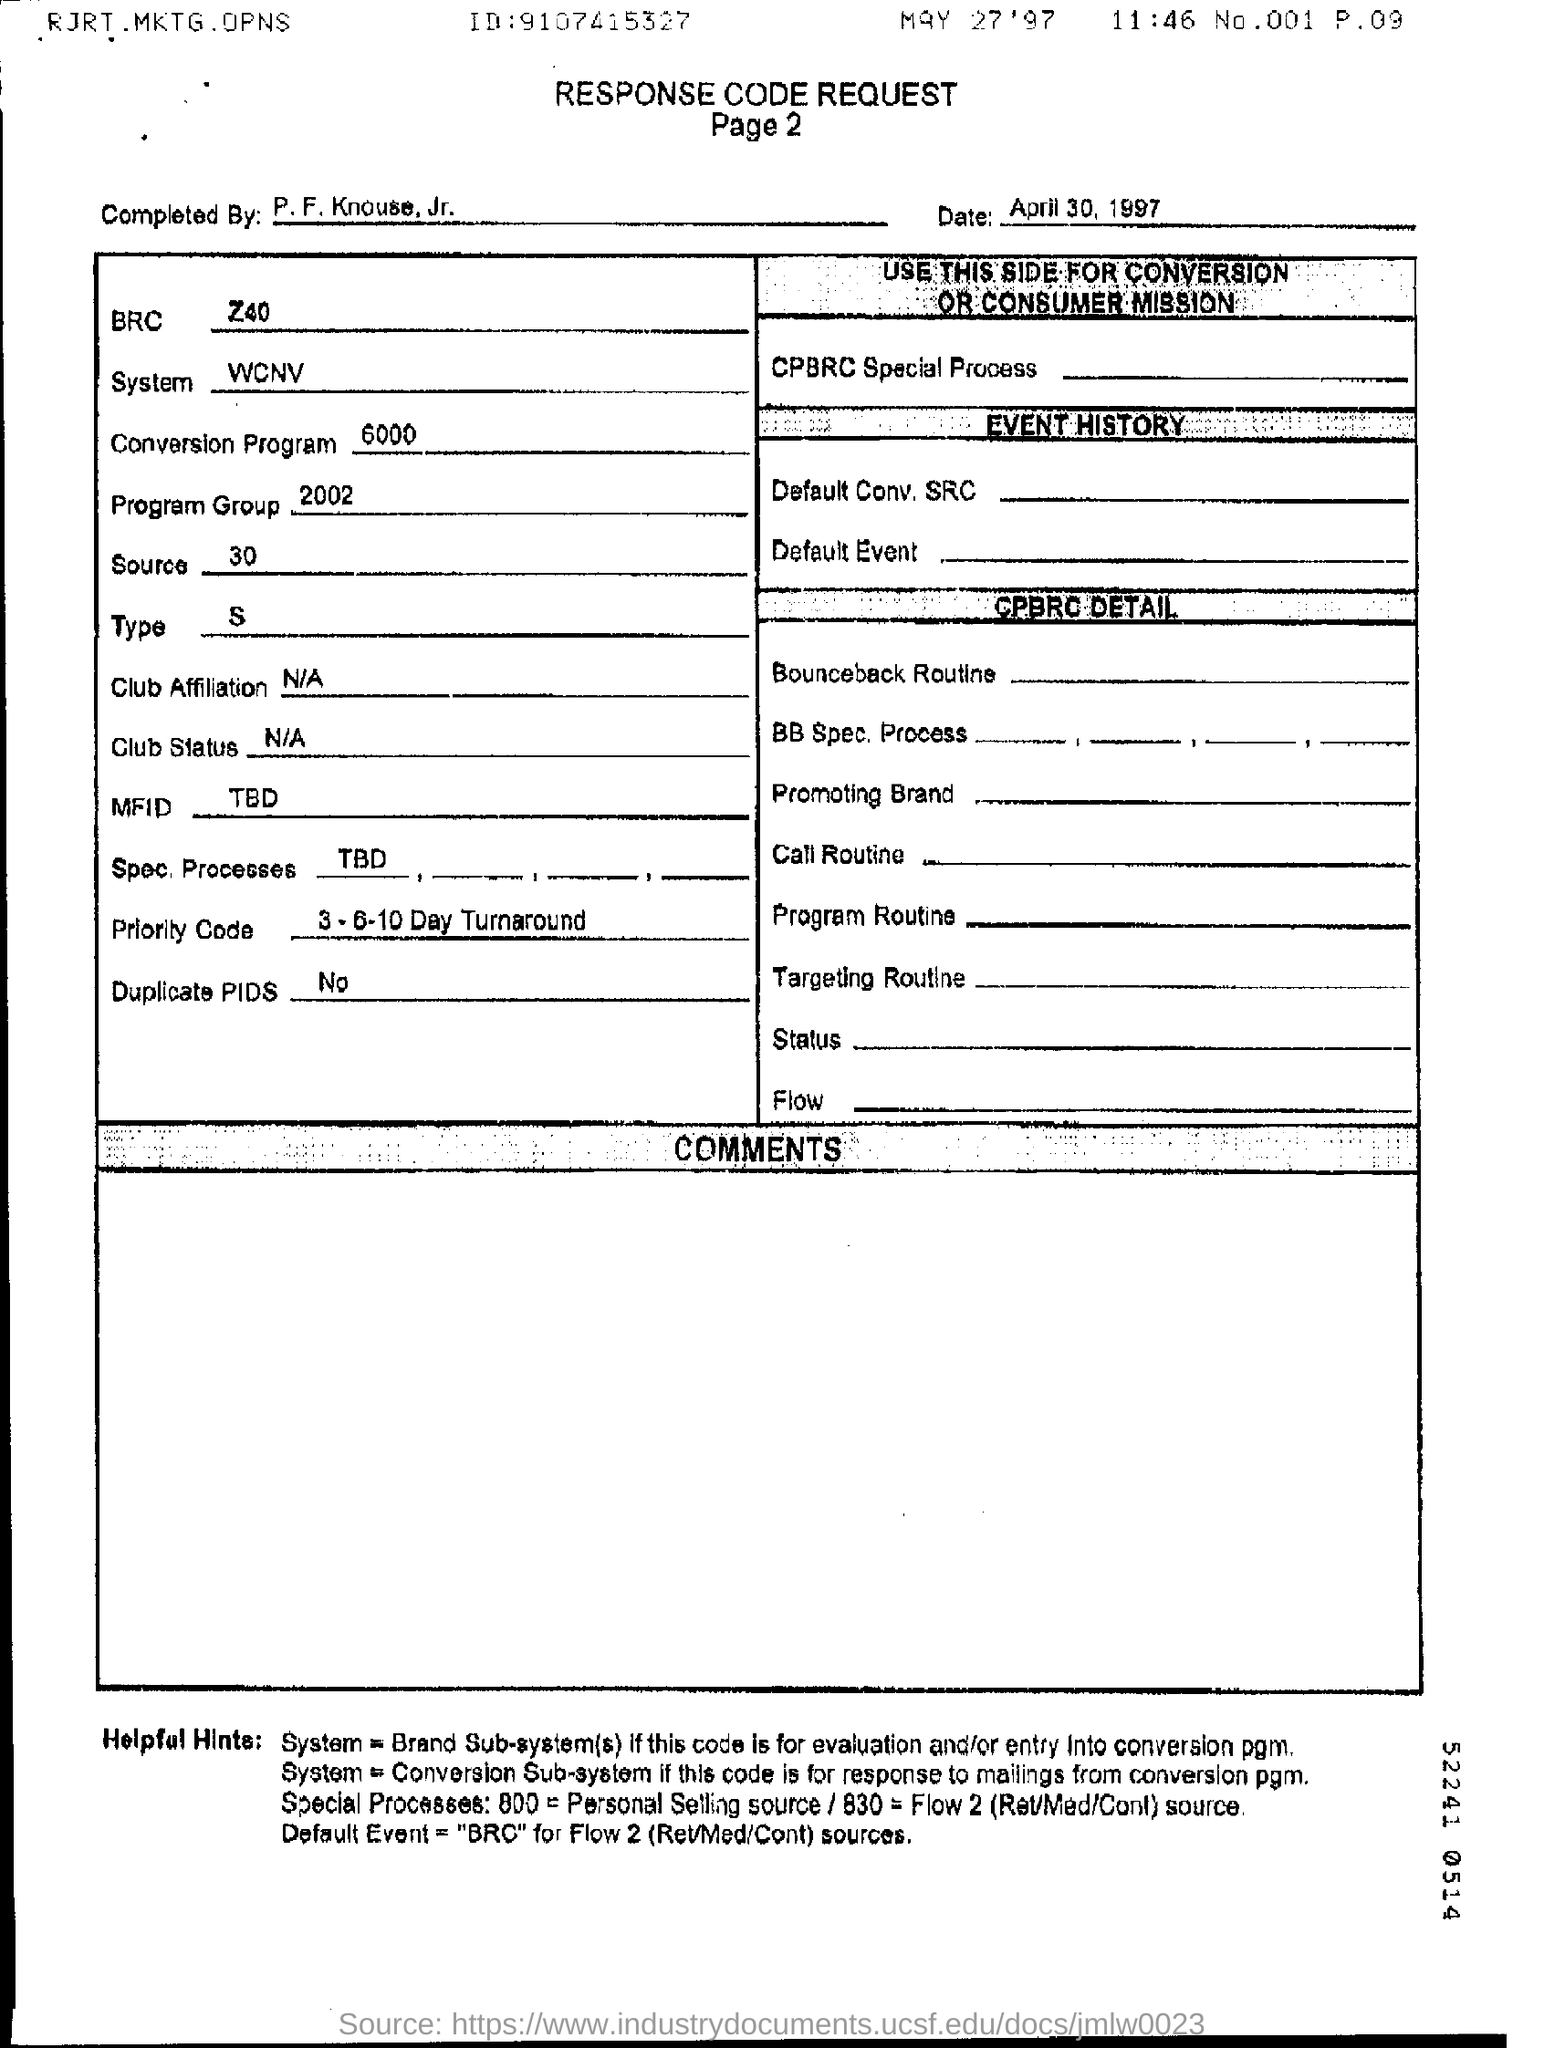Give some essential details in this illustration. The program group refers to a specific collection of related programs, with the year 2002 being one of the included dates. The Priority code is 3-6-10 Day Turnaround. The completion of the work titled 'Who is it?' was conducted by P. F. Knouse, Jr. The system is WCNV. The date is April 30, 1997. 